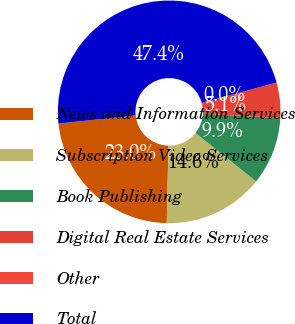<chart> <loc_0><loc_0><loc_500><loc_500><pie_chart><fcel>News and Information Services<fcel>Subscription Video Services<fcel>Book Publishing<fcel>Digital Real Estate Services<fcel>Other<fcel>Total<nl><fcel>22.98%<fcel>14.6%<fcel>9.86%<fcel>5.12%<fcel>0.01%<fcel>47.42%<nl></chart> 